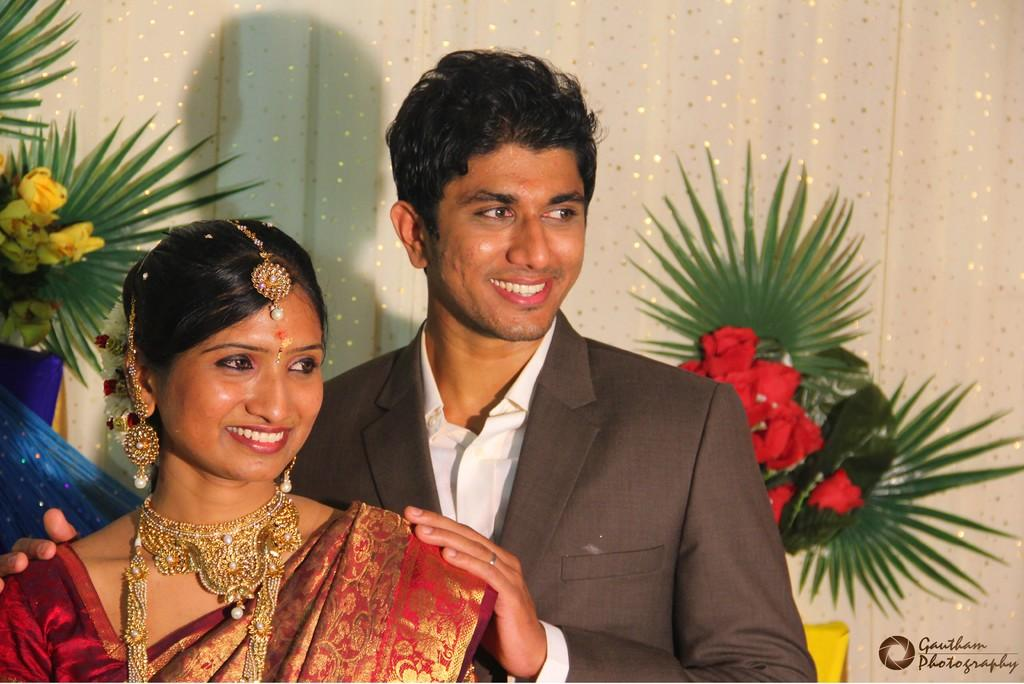How many people are in the foreground of the image? There are two persons in the foreground of the image. What can be seen in the background of the image? There are bouquets on a curtain and decoration items in the background of the image. Is there any text or symbol visible in the background? Yes, there is a logo visible in the background of the image. What type of location might the image be taken in? The image is likely taken in a hall. What type of fuel can be seen in the image? There is no fuel present in the image. Can you describe the clouds visible in the image? There are no clouds visible in the image. 